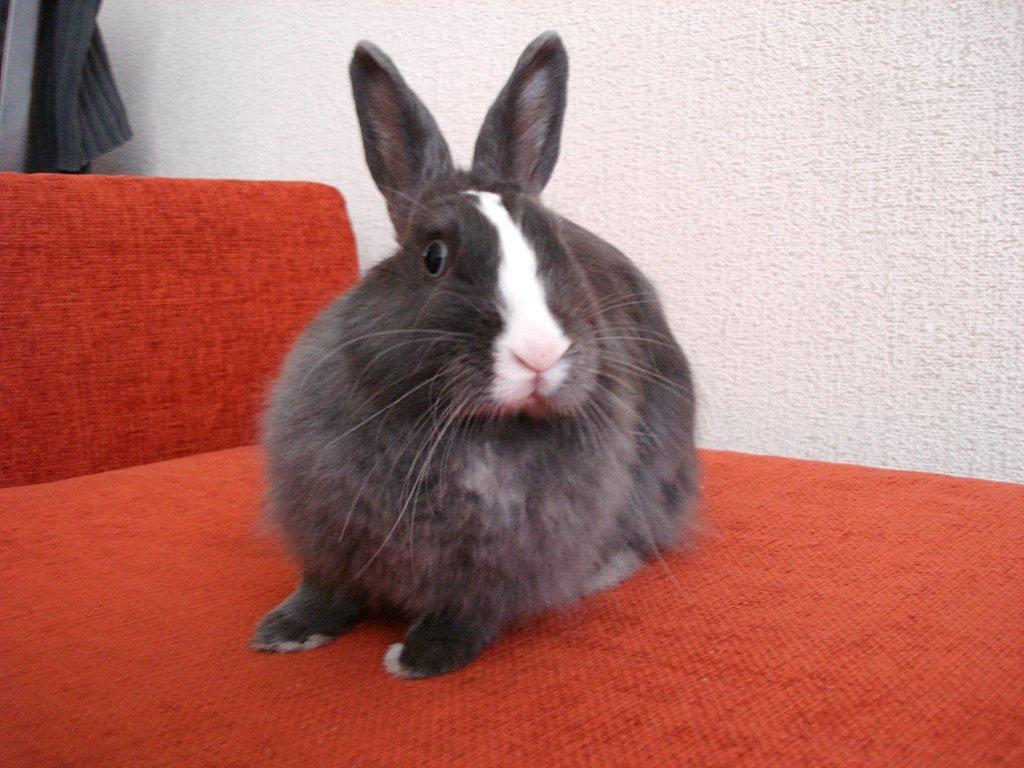Can you describe this image briefly? In this image I can see an orange colour thing and on it I can see a black and white colour rabbit. On the top left corner of this image I can see s cloth and in the background white colour wall. 